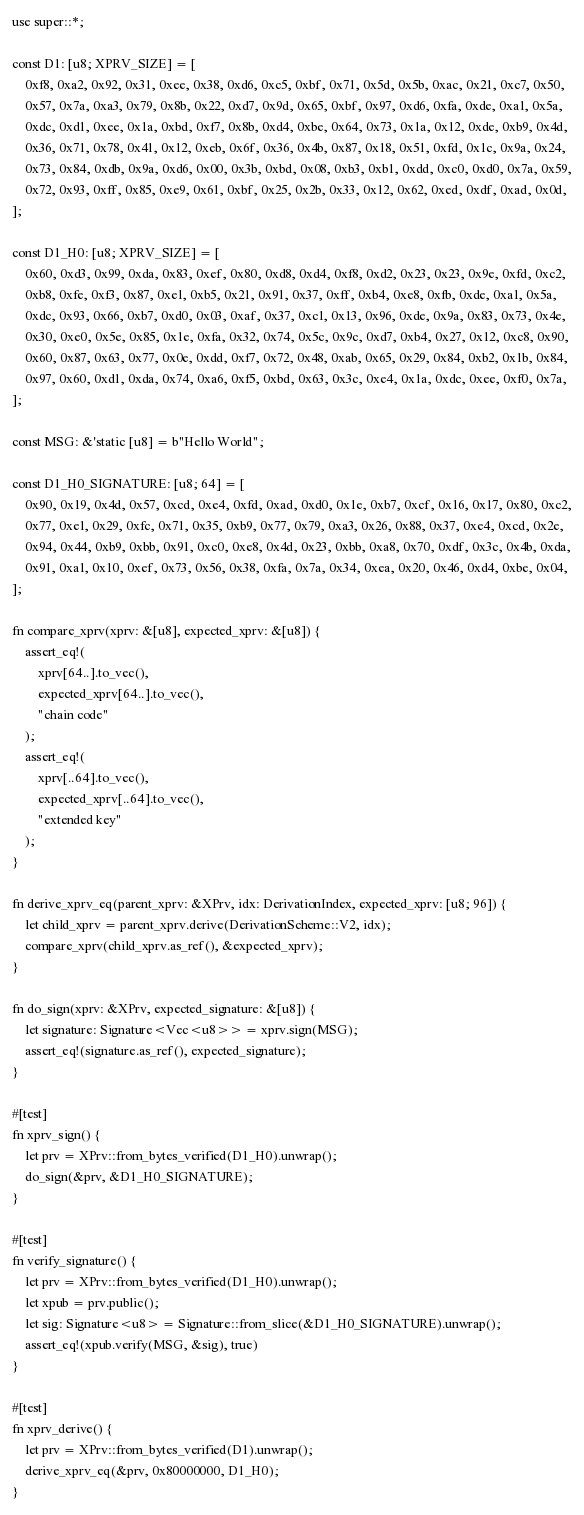Convert code to text. <code><loc_0><loc_0><loc_500><loc_500><_Rust_>use super::*;

const D1: [u8; XPRV_SIZE] = [
    0xf8, 0xa2, 0x92, 0x31, 0xee, 0x38, 0xd6, 0xc5, 0xbf, 0x71, 0x5d, 0x5b, 0xac, 0x21, 0xc7, 0x50,
    0x57, 0x7a, 0xa3, 0x79, 0x8b, 0x22, 0xd7, 0x9d, 0x65, 0xbf, 0x97, 0xd6, 0xfa, 0xde, 0xa1, 0x5a,
    0xdc, 0xd1, 0xee, 0x1a, 0xbd, 0xf7, 0x8b, 0xd4, 0xbe, 0x64, 0x73, 0x1a, 0x12, 0xde, 0xb9, 0x4d,
    0x36, 0x71, 0x78, 0x41, 0x12, 0xeb, 0x6f, 0x36, 0x4b, 0x87, 0x18, 0x51, 0xfd, 0x1c, 0x9a, 0x24,
    0x73, 0x84, 0xdb, 0x9a, 0xd6, 0x00, 0x3b, 0xbd, 0x08, 0xb3, 0xb1, 0xdd, 0xc0, 0xd0, 0x7a, 0x59,
    0x72, 0x93, 0xff, 0x85, 0xe9, 0x61, 0xbf, 0x25, 0x2b, 0x33, 0x12, 0x62, 0xed, 0xdf, 0xad, 0x0d,
];

const D1_H0: [u8; XPRV_SIZE] = [
    0x60, 0xd3, 0x99, 0xda, 0x83, 0xef, 0x80, 0xd8, 0xd4, 0xf8, 0xd2, 0x23, 0x23, 0x9e, 0xfd, 0xc2,
    0xb8, 0xfe, 0xf3, 0x87, 0xe1, 0xb5, 0x21, 0x91, 0x37, 0xff, 0xb4, 0xe8, 0xfb, 0xde, 0xa1, 0x5a,
    0xdc, 0x93, 0x66, 0xb7, 0xd0, 0x03, 0xaf, 0x37, 0xc1, 0x13, 0x96, 0xde, 0x9a, 0x83, 0x73, 0x4e,
    0x30, 0xe0, 0x5e, 0x85, 0x1e, 0xfa, 0x32, 0x74, 0x5c, 0x9c, 0xd7, 0xb4, 0x27, 0x12, 0xc8, 0x90,
    0x60, 0x87, 0x63, 0x77, 0x0e, 0xdd, 0xf7, 0x72, 0x48, 0xab, 0x65, 0x29, 0x84, 0xb2, 0x1b, 0x84,
    0x97, 0x60, 0xd1, 0xda, 0x74, 0xa6, 0xf5, 0xbd, 0x63, 0x3c, 0xe4, 0x1a, 0xdc, 0xee, 0xf0, 0x7a,
];

const MSG: &'static [u8] = b"Hello World";

const D1_H0_SIGNATURE: [u8; 64] = [
    0x90, 0x19, 0x4d, 0x57, 0xcd, 0xe4, 0xfd, 0xad, 0xd0, 0x1e, 0xb7, 0xcf, 0x16, 0x17, 0x80, 0xc2,
    0x77, 0xe1, 0x29, 0xfc, 0x71, 0x35, 0xb9, 0x77, 0x79, 0xa3, 0x26, 0x88, 0x37, 0xe4, 0xcd, 0x2e,
    0x94, 0x44, 0xb9, 0xbb, 0x91, 0xc0, 0xe8, 0x4d, 0x23, 0xbb, 0xa8, 0x70, 0xdf, 0x3c, 0x4b, 0xda,
    0x91, 0xa1, 0x10, 0xef, 0x73, 0x56, 0x38, 0xfa, 0x7a, 0x34, 0xea, 0x20, 0x46, 0xd4, 0xbe, 0x04,
];

fn compare_xprv(xprv: &[u8], expected_xprv: &[u8]) {
    assert_eq!(
        xprv[64..].to_vec(),
        expected_xprv[64..].to_vec(),
        "chain code"
    );
    assert_eq!(
        xprv[..64].to_vec(),
        expected_xprv[..64].to_vec(),
        "extended key"
    );
}

fn derive_xprv_eq(parent_xprv: &XPrv, idx: DerivationIndex, expected_xprv: [u8; 96]) {
    let child_xprv = parent_xprv.derive(DerivationScheme::V2, idx);
    compare_xprv(child_xprv.as_ref(), &expected_xprv);
}

fn do_sign(xprv: &XPrv, expected_signature: &[u8]) {
    let signature: Signature<Vec<u8>> = xprv.sign(MSG);
    assert_eq!(signature.as_ref(), expected_signature);
}

#[test]
fn xprv_sign() {
    let prv = XPrv::from_bytes_verified(D1_H0).unwrap();
    do_sign(&prv, &D1_H0_SIGNATURE);
}

#[test]
fn verify_signature() {
    let prv = XPrv::from_bytes_verified(D1_H0).unwrap();
    let xpub = prv.public();
    let sig: Signature<u8> = Signature::from_slice(&D1_H0_SIGNATURE).unwrap();
    assert_eq!(xpub.verify(MSG, &sig), true)
}

#[test]
fn xprv_derive() {
    let prv = XPrv::from_bytes_verified(D1).unwrap();
    derive_xprv_eq(&prv, 0x80000000, D1_H0);
}
</code> 